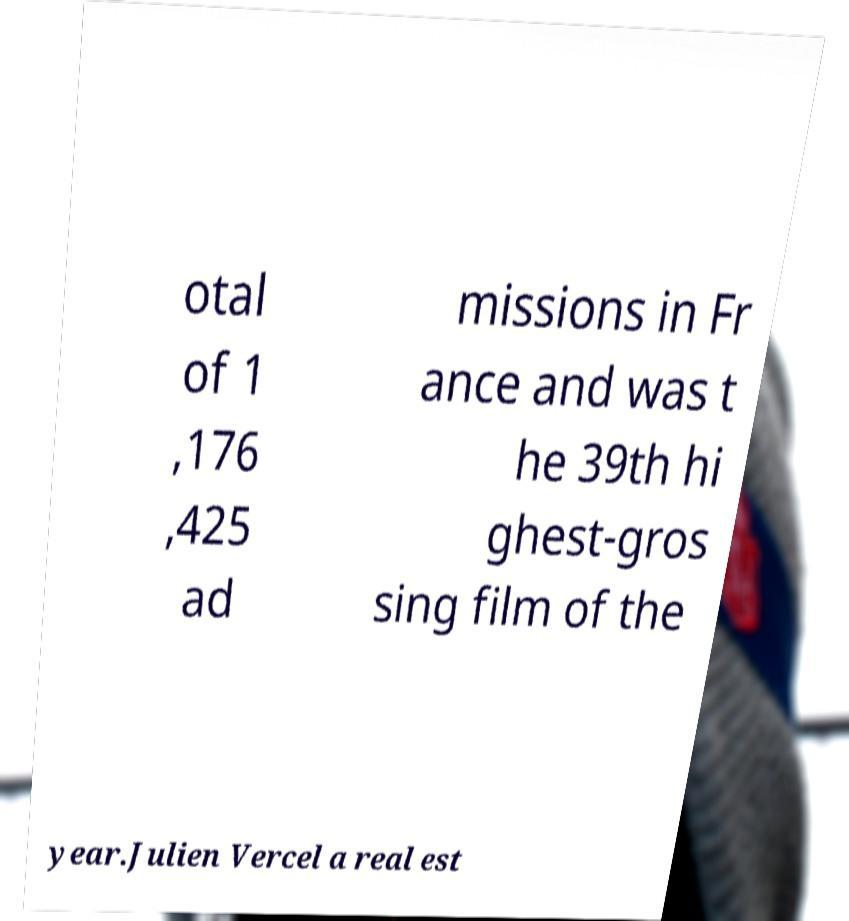Can you read and provide the text displayed in the image?This photo seems to have some interesting text. Can you extract and type it out for me? otal of 1 ,176 ,425 ad missions in Fr ance and was t he 39th hi ghest-gros sing film of the year.Julien Vercel a real est 